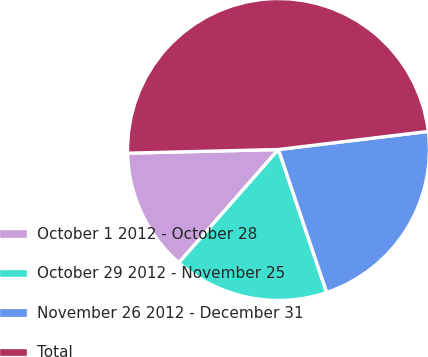<chart> <loc_0><loc_0><loc_500><loc_500><pie_chart><fcel>October 1 2012 - October 28<fcel>October 29 2012 - November 25<fcel>November 26 2012 - December 31<fcel>Total<nl><fcel>13.13%<fcel>16.66%<fcel>21.74%<fcel>48.47%<nl></chart> 